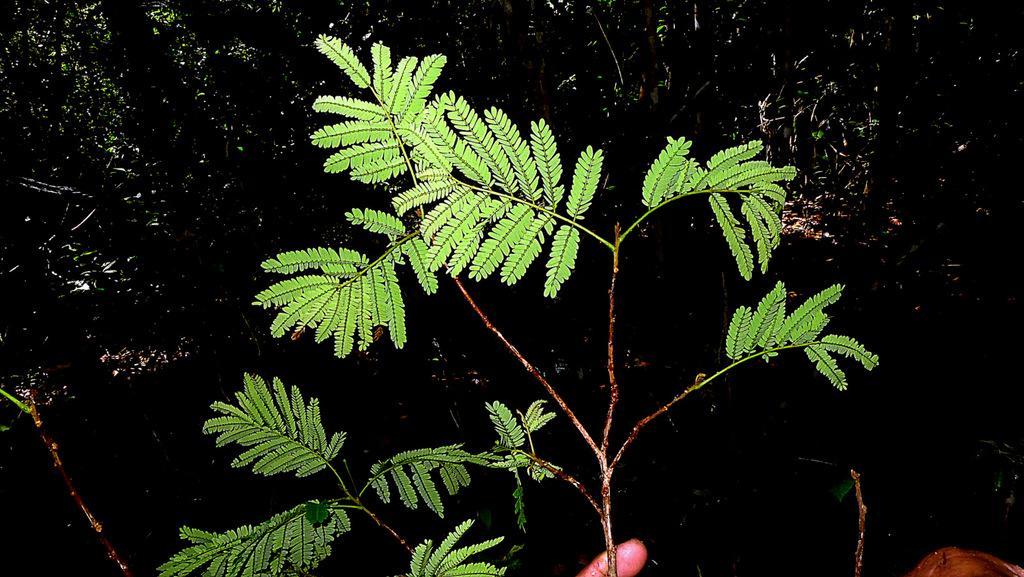Could you give a brief overview of what you see in this image? In the image plant, a person's finger and some other objects. The background of the image is dark. 